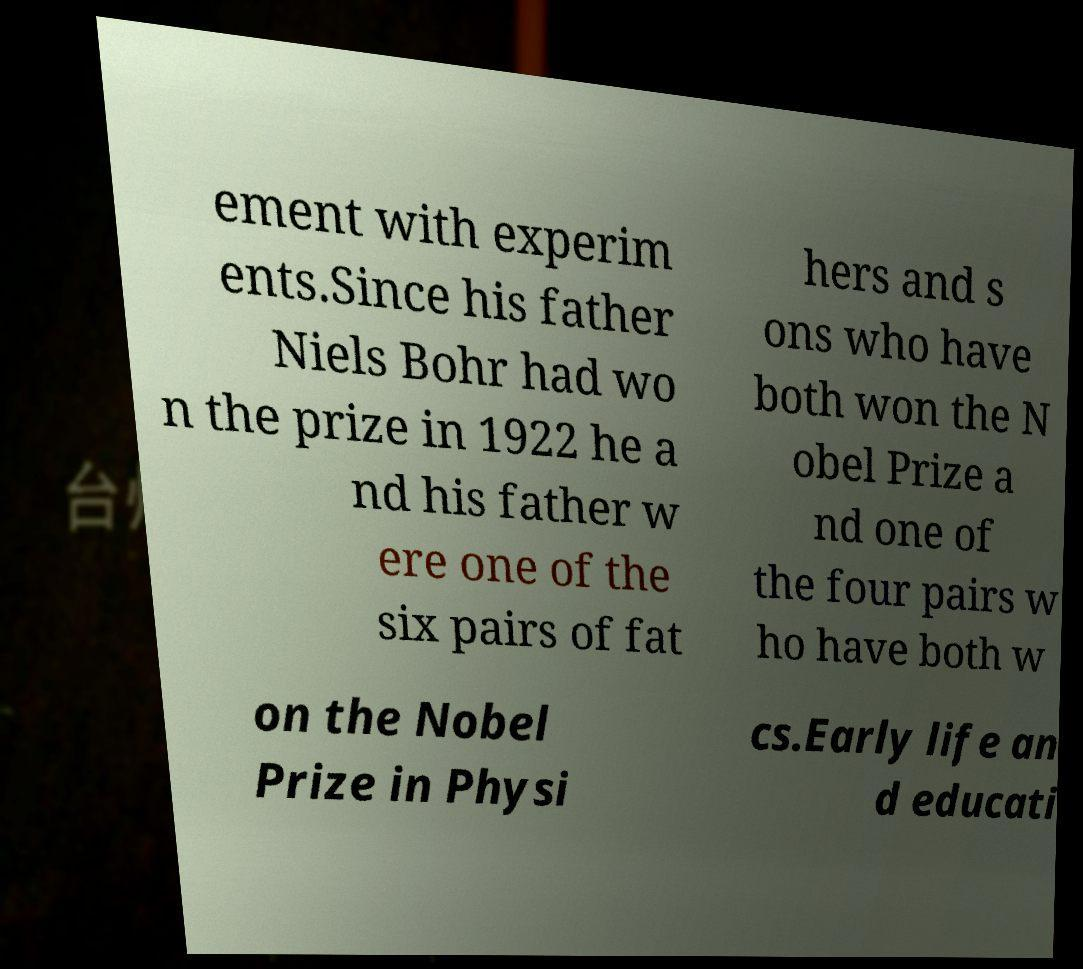Could you extract and type out the text from this image? ement with experim ents.Since his father Niels Bohr had wo n the prize in 1922 he a nd his father w ere one of the six pairs of fat hers and s ons who have both won the N obel Prize a nd one of the four pairs w ho have both w on the Nobel Prize in Physi cs.Early life an d educati 